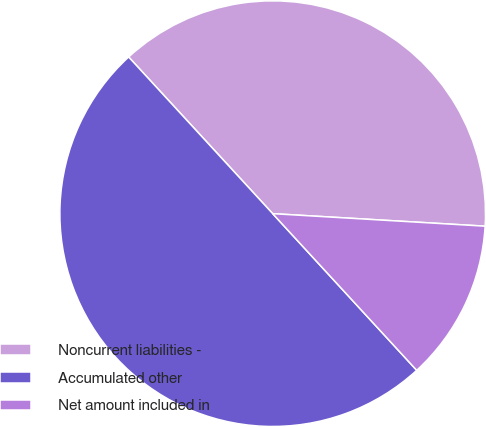<chart> <loc_0><loc_0><loc_500><loc_500><pie_chart><fcel>Noncurrent liabilities -<fcel>Accumulated other<fcel>Net amount included in<nl><fcel>37.77%<fcel>50.0%<fcel>12.23%<nl></chart> 